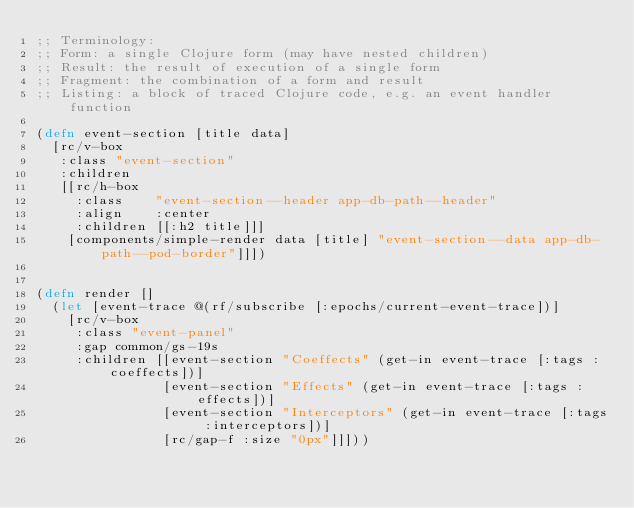Convert code to text. <code><loc_0><loc_0><loc_500><loc_500><_Clojure_>;; Terminology:
;; Form: a single Clojure form (may have nested children)
;; Result: the result of execution of a single form
;; Fragment: the combination of a form and result
;; Listing: a block of traced Clojure code, e.g. an event handler function

(defn event-section [title data]
  [rc/v-box
   :class "event-section"
   :children
   [[rc/h-box
     :class    "event-section--header app-db-path--header"
     :align    :center
     :children [[:h2 title]]]
    [components/simple-render data [title] "event-section--data app-db-path--pod-border"]]])


(defn render []
  (let [event-trace @(rf/subscribe [:epochs/current-event-trace])]
    [rc/v-box
     :class "event-panel"
     :gap common/gs-19s
     :children [[event-section "Coeffects" (get-in event-trace [:tags :coeffects])]
                [event-section "Effects" (get-in event-trace [:tags :effects])]
                [event-section "Interceptors" (get-in event-trace [:tags :interceptors])]
                [rc/gap-f :size "0px"]]]))
</code> 